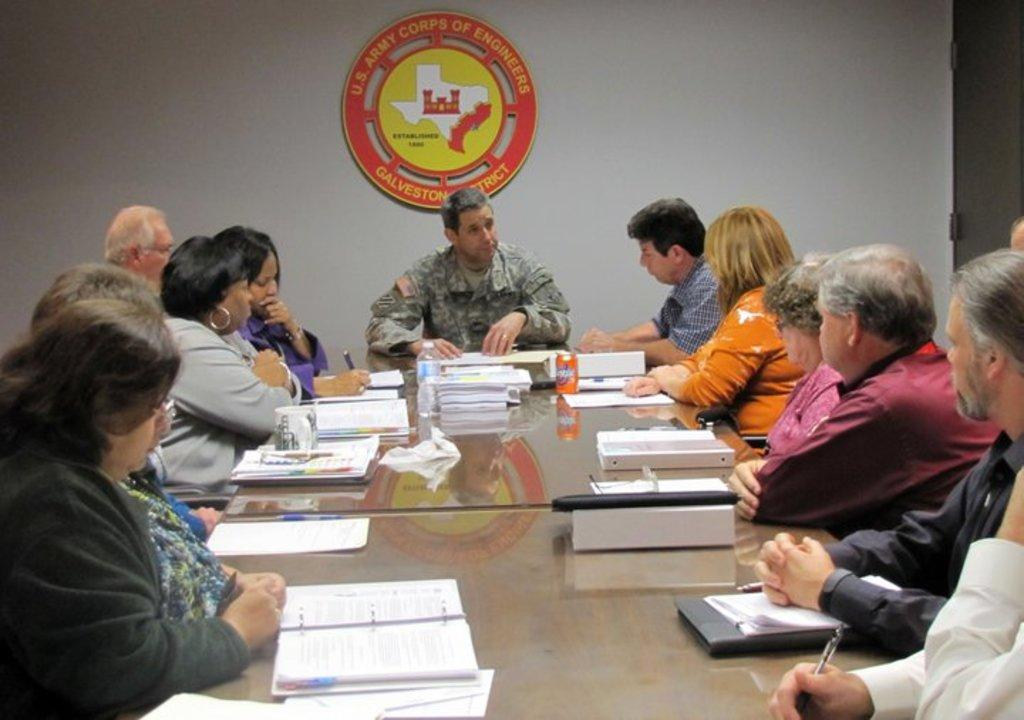How many people are in the image? There are persons in the image, but the exact number is not specified. What are the persons wearing? The persons are wearing clothes. Where are the persons located in relation to the table? The persons are sitting in front of a table. What is on the table? The table contains files. What can be seen at the top of the image? There is a logo at the top of the image. How many giants are present in the image? There are no giants present in the image; it features persons sitting in front of a table. What trick is being performed by the persons in the image? There is no trick being performed by the persons in the image; they are simply sitting in front of a table with files on it. 